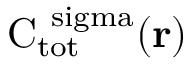Convert formula to latex. <formula><loc_0><loc_0><loc_500><loc_500>{ C } _ { \mathrm { t o t } } ^ { \ s i g m a } ( { r } )</formula> 